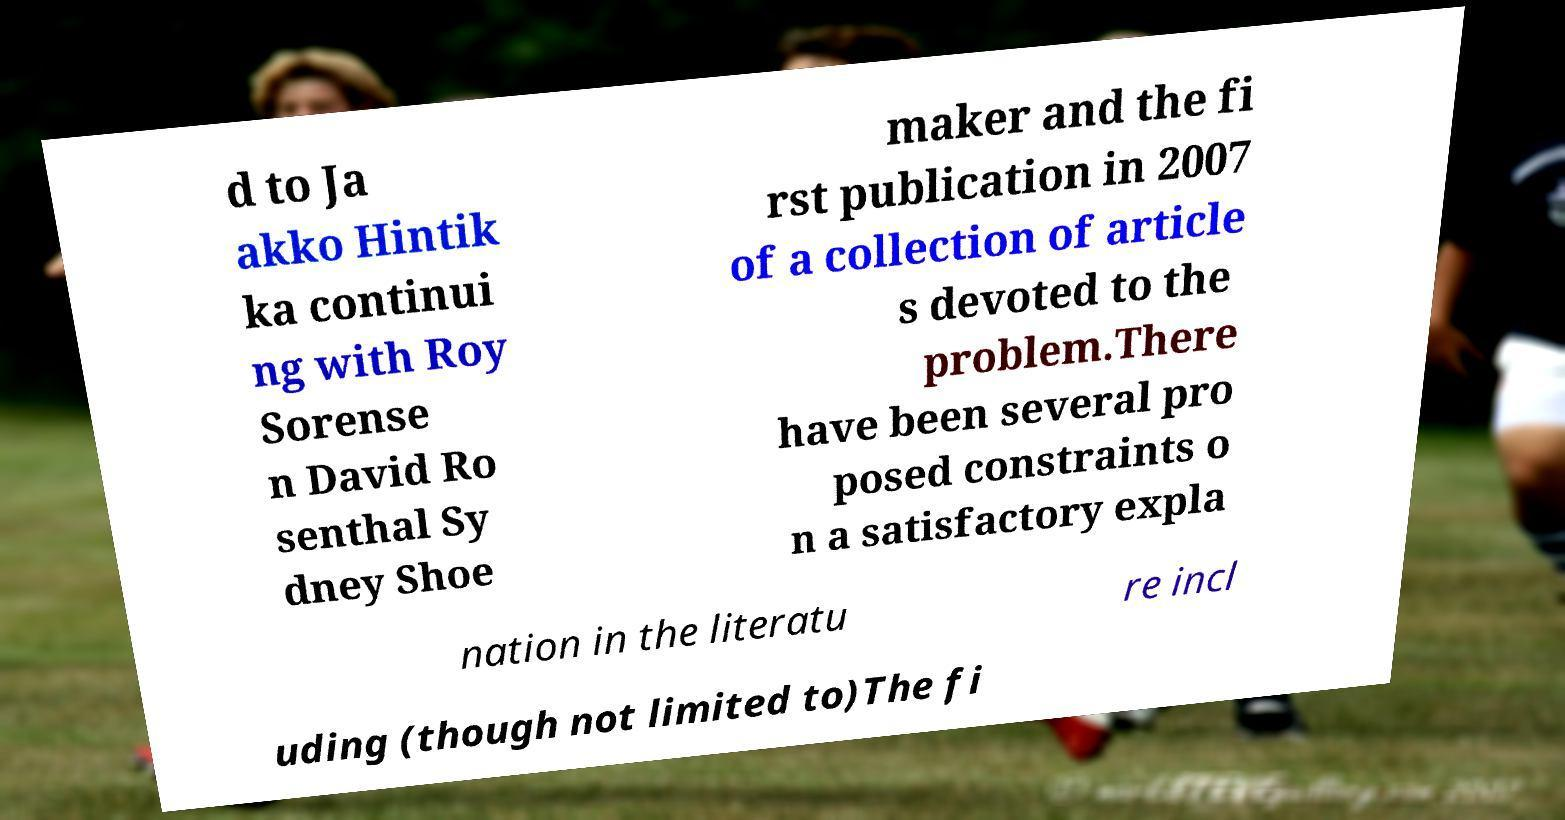I need the written content from this picture converted into text. Can you do that? d to Ja akko Hintik ka continui ng with Roy Sorense n David Ro senthal Sy dney Shoe maker and the fi rst publication in 2007 of a collection of article s devoted to the problem.There have been several pro posed constraints o n a satisfactory expla nation in the literatu re incl uding (though not limited to)The fi 